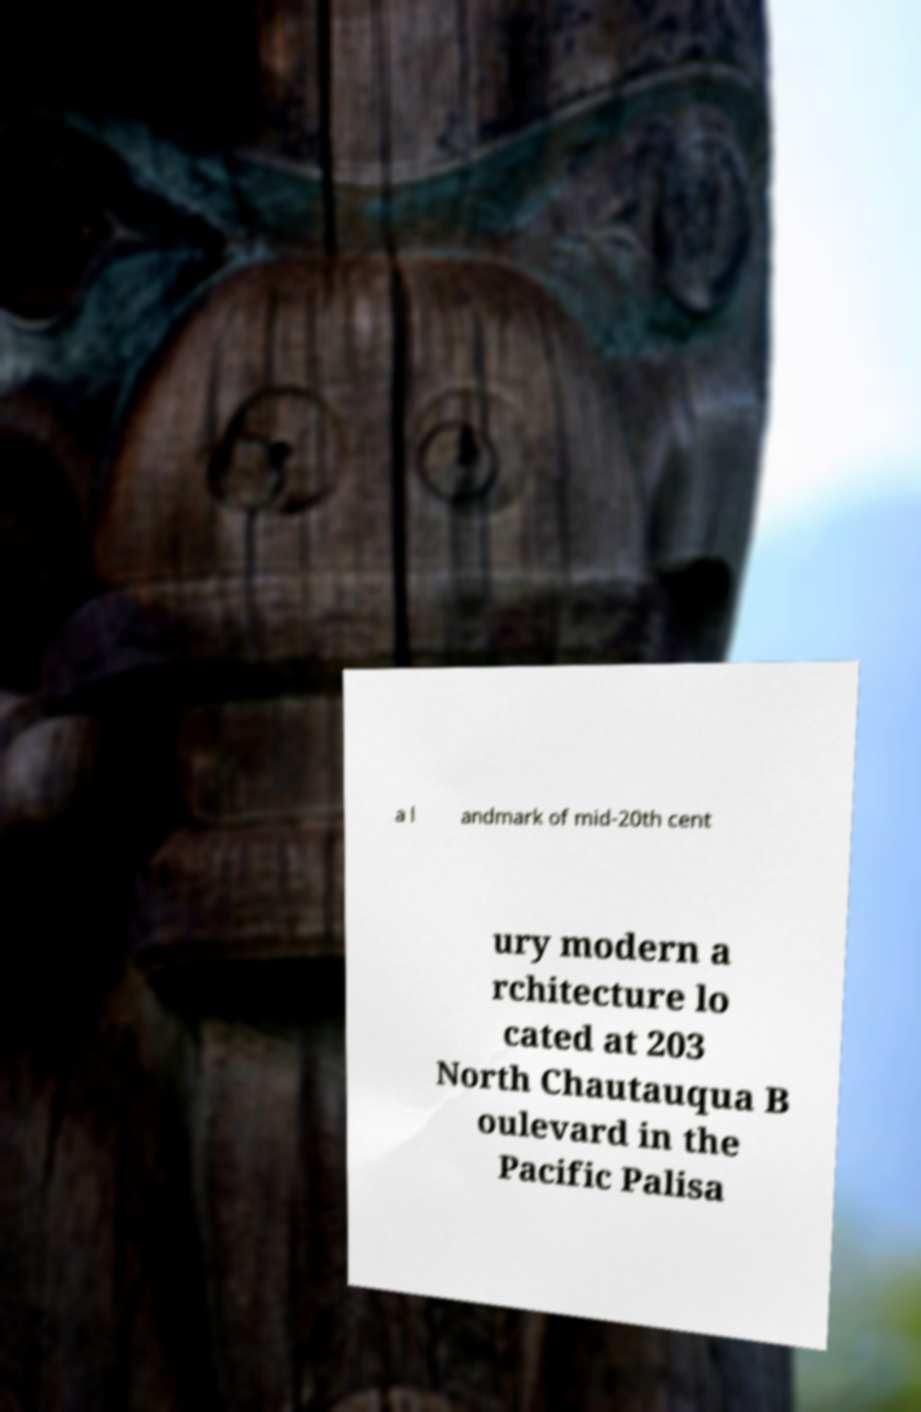I need the written content from this picture converted into text. Can you do that? a l andmark of mid-20th cent ury modern a rchitecture lo cated at 203 North Chautauqua B oulevard in the Pacific Palisa 